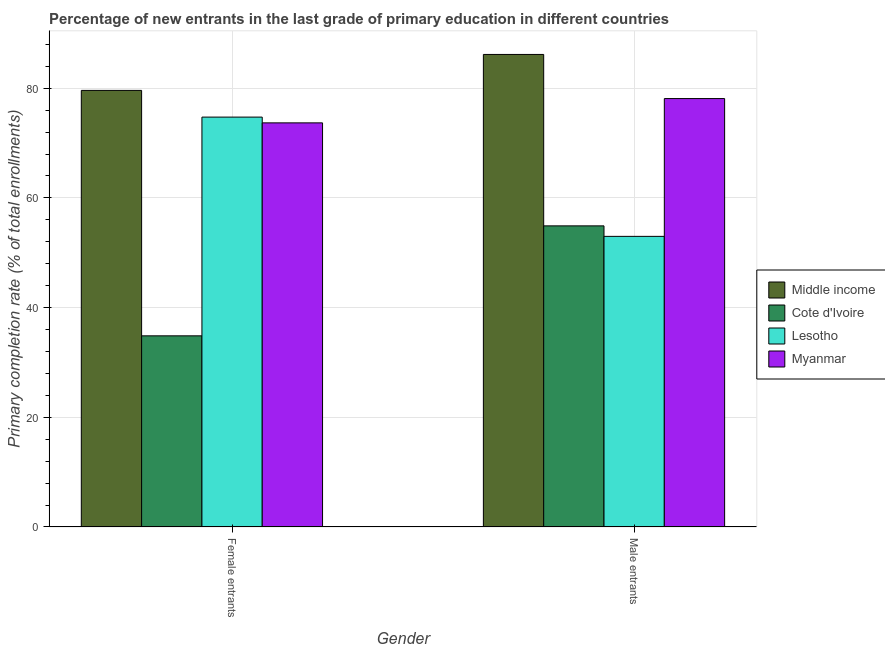How many groups of bars are there?
Offer a terse response. 2. Are the number of bars on each tick of the X-axis equal?
Make the answer very short. Yes. How many bars are there on the 1st tick from the right?
Offer a very short reply. 4. What is the label of the 2nd group of bars from the left?
Offer a terse response. Male entrants. What is the primary completion rate of male entrants in Cote d'Ivoire?
Your answer should be compact. 54.9. Across all countries, what is the maximum primary completion rate of male entrants?
Give a very brief answer. 86.15. Across all countries, what is the minimum primary completion rate of male entrants?
Your answer should be compact. 52.99. In which country was the primary completion rate of female entrants minimum?
Offer a very short reply. Cote d'Ivoire. What is the total primary completion rate of female entrants in the graph?
Your answer should be compact. 262.87. What is the difference between the primary completion rate of female entrants in Cote d'Ivoire and that in Lesotho?
Your answer should be compact. -39.88. What is the difference between the primary completion rate of female entrants in Cote d'Ivoire and the primary completion rate of male entrants in Myanmar?
Give a very brief answer. -43.26. What is the average primary completion rate of female entrants per country?
Provide a short and direct response. 65.72. What is the difference between the primary completion rate of female entrants and primary completion rate of male entrants in Middle income?
Your answer should be compact. -6.55. In how many countries, is the primary completion rate of male entrants greater than 56 %?
Your answer should be very brief. 2. What is the ratio of the primary completion rate of female entrants in Middle income to that in Myanmar?
Offer a terse response. 1.08. In how many countries, is the primary completion rate of female entrants greater than the average primary completion rate of female entrants taken over all countries?
Your answer should be compact. 3. What does the 4th bar from the left in Male entrants represents?
Your response must be concise. Myanmar. What does the 2nd bar from the right in Female entrants represents?
Your answer should be very brief. Lesotho. How many bars are there?
Provide a short and direct response. 8. Are all the bars in the graph horizontal?
Offer a very short reply. No. How many countries are there in the graph?
Provide a succinct answer. 4. What is the difference between two consecutive major ticks on the Y-axis?
Your answer should be compact. 20. Does the graph contain grids?
Offer a terse response. Yes. How many legend labels are there?
Your response must be concise. 4. What is the title of the graph?
Keep it short and to the point. Percentage of new entrants in the last grade of primary education in different countries. What is the label or title of the Y-axis?
Provide a succinct answer. Primary completion rate (% of total enrollments). What is the Primary completion rate (% of total enrollments) of Middle income in Female entrants?
Keep it short and to the point. 79.6. What is the Primary completion rate (% of total enrollments) in Cote d'Ivoire in Female entrants?
Offer a very short reply. 34.85. What is the Primary completion rate (% of total enrollments) of Lesotho in Female entrants?
Keep it short and to the point. 74.73. What is the Primary completion rate (% of total enrollments) of Myanmar in Female entrants?
Give a very brief answer. 73.68. What is the Primary completion rate (% of total enrollments) of Middle income in Male entrants?
Offer a terse response. 86.15. What is the Primary completion rate (% of total enrollments) of Cote d'Ivoire in Male entrants?
Your answer should be compact. 54.9. What is the Primary completion rate (% of total enrollments) of Lesotho in Male entrants?
Provide a short and direct response. 52.99. What is the Primary completion rate (% of total enrollments) in Myanmar in Male entrants?
Provide a short and direct response. 78.11. Across all Gender, what is the maximum Primary completion rate (% of total enrollments) of Middle income?
Your answer should be very brief. 86.15. Across all Gender, what is the maximum Primary completion rate (% of total enrollments) in Cote d'Ivoire?
Your answer should be compact. 54.9. Across all Gender, what is the maximum Primary completion rate (% of total enrollments) of Lesotho?
Your answer should be very brief. 74.73. Across all Gender, what is the maximum Primary completion rate (% of total enrollments) of Myanmar?
Your answer should be compact. 78.11. Across all Gender, what is the minimum Primary completion rate (% of total enrollments) of Middle income?
Offer a very short reply. 79.6. Across all Gender, what is the minimum Primary completion rate (% of total enrollments) of Cote d'Ivoire?
Offer a very short reply. 34.85. Across all Gender, what is the minimum Primary completion rate (% of total enrollments) in Lesotho?
Give a very brief answer. 52.99. Across all Gender, what is the minimum Primary completion rate (% of total enrollments) in Myanmar?
Make the answer very short. 73.68. What is the total Primary completion rate (% of total enrollments) in Middle income in the graph?
Provide a succinct answer. 165.76. What is the total Primary completion rate (% of total enrollments) of Cote d'Ivoire in the graph?
Your response must be concise. 89.76. What is the total Primary completion rate (% of total enrollments) in Lesotho in the graph?
Make the answer very short. 127.72. What is the total Primary completion rate (% of total enrollments) of Myanmar in the graph?
Make the answer very short. 151.79. What is the difference between the Primary completion rate (% of total enrollments) of Middle income in Female entrants and that in Male entrants?
Make the answer very short. -6.55. What is the difference between the Primary completion rate (% of total enrollments) of Cote d'Ivoire in Female entrants and that in Male entrants?
Provide a short and direct response. -20.05. What is the difference between the Primary completion rate (% of total enrollments) in Lesotho in Female entrants and that in Male entrants?
Offer a very short reply. 21.74. What is the difference between the Primary completion rate (% of total enrollments) of Myanmar in Female entrants and that in Male entrants?
Offer a terse response. -4.43. What is the difference between the Primary completion rate (% of total enrollments) of Middle income in Female entrants and the Primary completion rate (% of total enrollments) of Cote d'Ivoire in Male entrants?
Provide a succinct answer. 24.7. What is the difference between the Primary completion rate (% of total enrollments) of Middle income in Female entrants and the Primary completion rate (% of total enrollments) of Lesotho in Male entrants?
Your response must be concise. 26.61. What is the difference between the Primary completion rate (% of total enrollments) in Middle income in Female entrants and the Primary completion rate (% of total enrollments) in Myanmar in Male entrants?
Ensure brevity in your answer.  1.49. What is the difference between the Primary completion rate (% of total enrollments) of Cote d'Ivoire in Female entrants and the Primary completion rate (% of total enrollments) of Lesotho in Male entrants?
Keep it short and to the point. -18.13. What is the difference between the Primary completion rate (% of total enrollments) of Cote d'Ivoire in Female entrants and the Primary completion rate (% of total enrollments) of Myanmar in Male entrants?
Ensure brevity in your answer.  -43.26. What is the difference between the Primary completion rate (% of total enrollments) in Lesotho in Female entrants and the Primary completion rate (% of total enrollments) in Myanmar in Male entrants?
Your answer should be very brief. -3.38. What is the average Primary completion rate (% of total enrollments) of Middle income per Gender?
Make the answer very short. 82.88. What is the average Primary completion rate (% of total enrollments) in Cote d'Ivoire per Gender?
Your response must be concise. 44.88. What is the average Primary completion rate (% of total enrollments) in Lesotho per Gender?
Your answer should be very brief. 63.86. What is the average Primary completion rate (% of total enrollments) in Myanmar per Gender?
Your answer should be very brief. 75.89. What is the difference between the Primary completion rate (% of total enrollments) in Middle income and Primary completion rate (% of total enrollments) in Cote d'Ivoire in Female entrants?
Make the answer very short. 44.75. What is the difference between the Primary completion rate (% of total enrollments) of Middle income and Primary completion rate (% of total enrollments) of Lesotho in Female entrants?
Offer a terse response. 4.87. What is the difference between the Primary completion rate (% of total enrollments) of Middle income and Primary completion rate (% of total enrollments) of Myanmar in Female entrants?
Offer a terse response. 5.92. What is the difference between the Primary completion rate (% of total enrollments) in Cote d'Ivoire and Primary completion rate (% of total enrollments) in Lesotho in Female entrants?
Offer a very short reply. -39.88. What is the difference between the Primary completion rate (% of total enrollments) of Cote d'Ivoire and Primary completion rate (% of total enrollments) of Myanmar in Female entrants?
Offer a very short reply. -38.83. What is the difference between the Primary completion rate (% of total enrollments) in Lesotho and Primary completion rate (% of total enrollments) in Myanmar in Female entrants?
Your answer should be compact. 1.05. What is the difference between the Primary completion rate (% of total enrollments) of Middle income and Primary completion rate (% of total enrollments) of Cote d'Ivoire in Male entrants?
Provide a succinct answer. 31.25. What is the difference between the Primary completion rate (% of total enrollments) in Middle income and Primary completion rate (% of total enrollments) in Lesotho in Male entrants?
Offer a very short reply. 33.17. What is the difference between the Primary completion rate (% of total enrollments) of Middle income and Primary completion rate (% of total enrollments) of Myanmar in Male entrants?
Your answer should be very brief. 8.04. What is the difference between the Primary completion rate (% of total enrollments) in Cote d'Ivoire and Primary completion rate (% of total enrollments) in Lesotho in Male entrants?
Give a very brief answer. 1.92. What is the difference between the Primary completion rate (% of total enrollments) of Cote d'Ivoire and Primary completion rate (% of total enrollments) of Myanmar in Male entrants?
Your answer should be compact. -23.21. What is the difference between the Primary completion rate (% of total enrollments) of Lesotho and Primary completion rate (% of total enrollments) of Myanmar in Male entrants?
Offer a terse response. -25.12. What is the ratio of the Primary completion rate (% of total enrollments) in Middle income in Female entrants to that in Male entrants?
Your response must be concise. 0.92. What is the ratio of the Primary completion rate (% of total enrollments) in Cote d'Ivoire in Female entrants to that in Male entrants?
Offer a very short reply. 0.63. What is the ratio of the Primary completion rate (% of total enrollments) in Lesotho in Female entrants to that in Male entrants?
Your answer should be very brief. 1.41. What is the ratio of the Primary completion rate (% of total enrollments) of Myanmar in Female entrants to that in Male entrants?
Offer a terse response. 0.94. What is the difference between the highest and the second highest Primary completion rate (% of total enrollments) in Middle income?
Provide a short and direct response. 6.55. What is the difference between the highest and the second highest Primary completion rate (% of total enrollments) of Cote d'Ivoire?
Give a very brief answer. 20.05. What is the difference between the highest and the second highest Primary completion rate (% of total enrollments) of Lesotho?
Your answer should be very brief. 21.74. What is the difference between the highest and the second highest Primary completion rate (% of total enrollments) of Myanmar?
Your answer should be compact. 4.43. What is the difference between the highest and the lowest Primary completion rate (% of total enrollments) in Middle income?
Your answer should be compact. 6.55. What is the difference between the highest and the lowest Primary completion rate (% of total enrollments) in Cote d'Ivoire?
Make the answer very short. 20.05. What is the difference between the highest and the lowest Primary completion rate (% of total enrollments) of Lesotho?
Keep it short and to the point. 21.74. What is the difference between the highest and the lowest Primary completion rate (% of total enrollments) in Myanmar?
Make the answer very short. 4.43. 